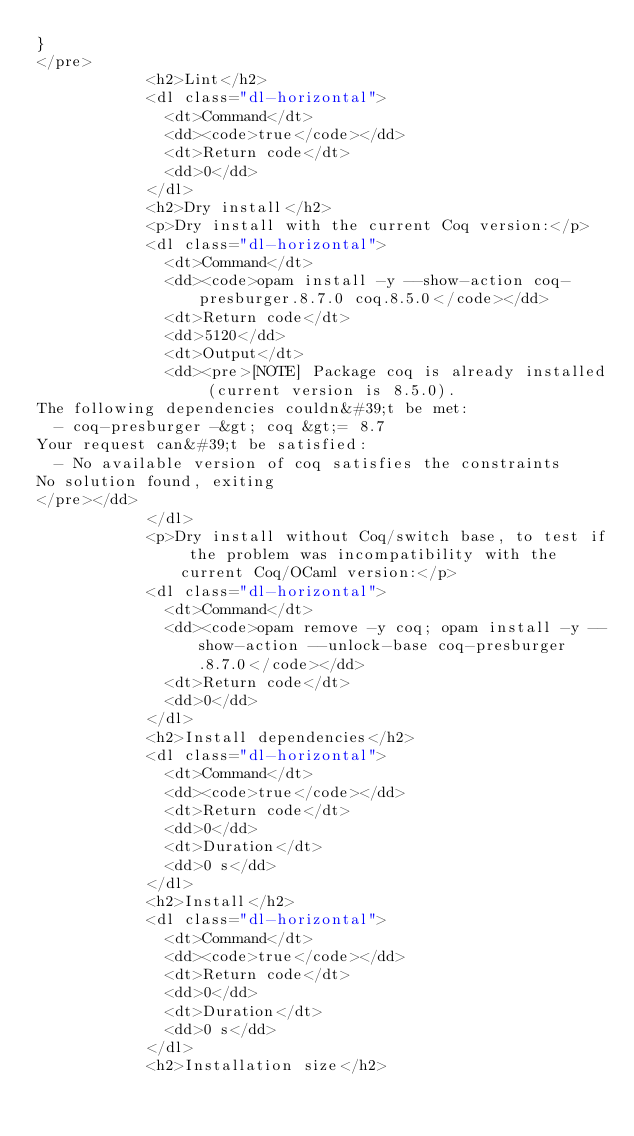Convert code to text. <code><loc_0><loc_0><loc_500><loc_500><_HTML_>}
</pre>
            <h2>Lint</h2>
            <dl class="dl-horizontal">
              <dt>Command</dt>
              <dd><code>true</code></dd>
              <dt>Return code</dt>
              <dd>0</dd>
            </dl>
            <h2>Dry install</h2>
            <p>Dry install with the current Coq version:</p>
            <dl class="dl-horizontal">
              <dt>Command</dt>
              <dd><code>opam install -y --show-action coq-presburger.8.7.0 coq.8.5.0</code></dd>
              <dt>Return code</dt>
              <dd>5120</dd>
              <dt>Output</dt>
              <dd><pre>[NOTE] Package coq is already installed (current version is 8.5.0).
The following dependencies couldn&#39;t be met:
  - coq-presburger -&gt; coq &gt;= 8.7
Your request can&#39;t be satisfied:
  - No available version of coq satisfies the constraints
No solution found, exiting
</pre></dd>
            </dl>
            <p>Dry install without Coq/switch base, to test if the problem was incompatibility with the current Coq/OCaml version:</p>
            <dl class="dl-horizontal">
              <dt>Command</dt>
              <dd><code>opam remove -y coq; opam install -y --show-action --unlock-base coq-presburger.8.7.0</code></dd>
              <dt>Return code</dt>
              <dd>0</dd>
            </dl>
            <h2>Install dependencies</h2>
            <dl class="dl-horizontal">
              <dt>Command</dt>
              <dd><code>true</code></dd>
              <dt>Return code</dt>
              <dd>0</dd>
              <dt>Duration</dt>
              <dd>0 s</dd>
            </dl>
            <h2>Install</h2>
            <dl class="dl-horizontal">
              <dt>Command</dt>
              <dd><code>true</code></dd>
              <dt>Return code</dt>
              <dd>0</dd>
              <dt>Duration</dt>
              <dd>0 s</dd>
            </dl>
            <h2>Installation size</h2></code> 